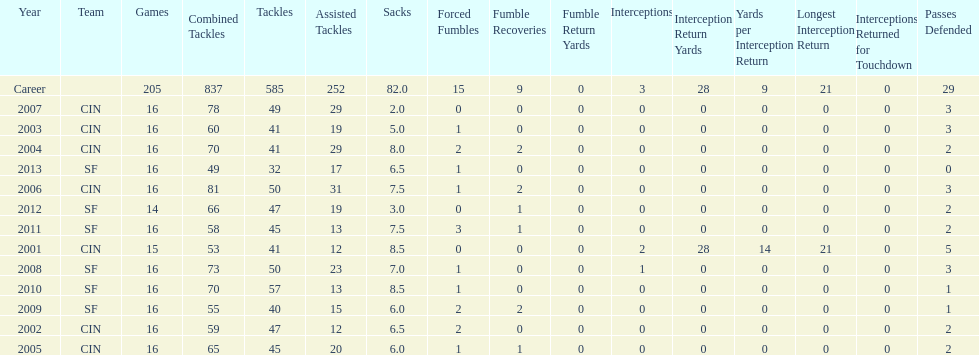How many years did he play where he did not recover a fumble? 7. 